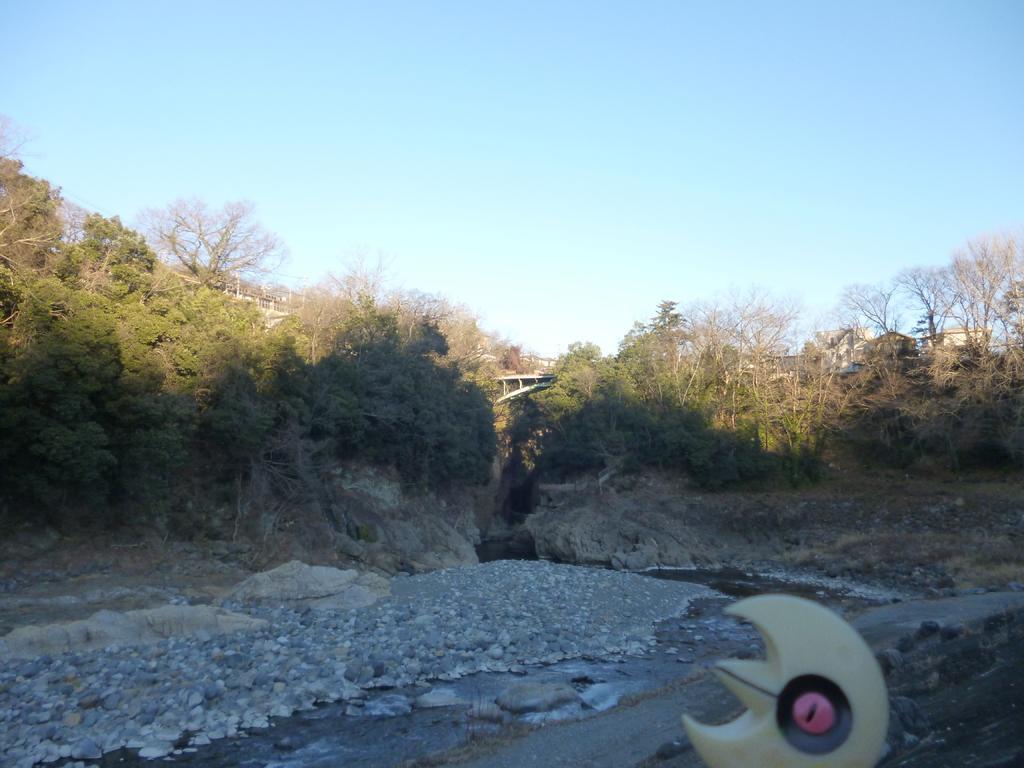Could you give a brief overview of what you see in this image? In this image there are stones at the bottom. At the top there is the sky. In the middle there are trees. At the bottom there is a small object on the ground. In the middle it seems like a bridge. 